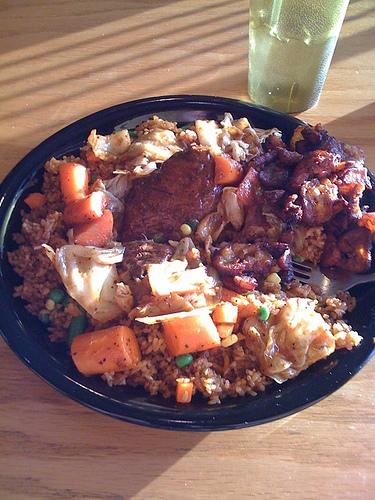What is the color of the glass?
Concise answer only. Green. Where is the fork?
Concise answer only. In food. Where are the carrots?
Quick response, please. Plate. 